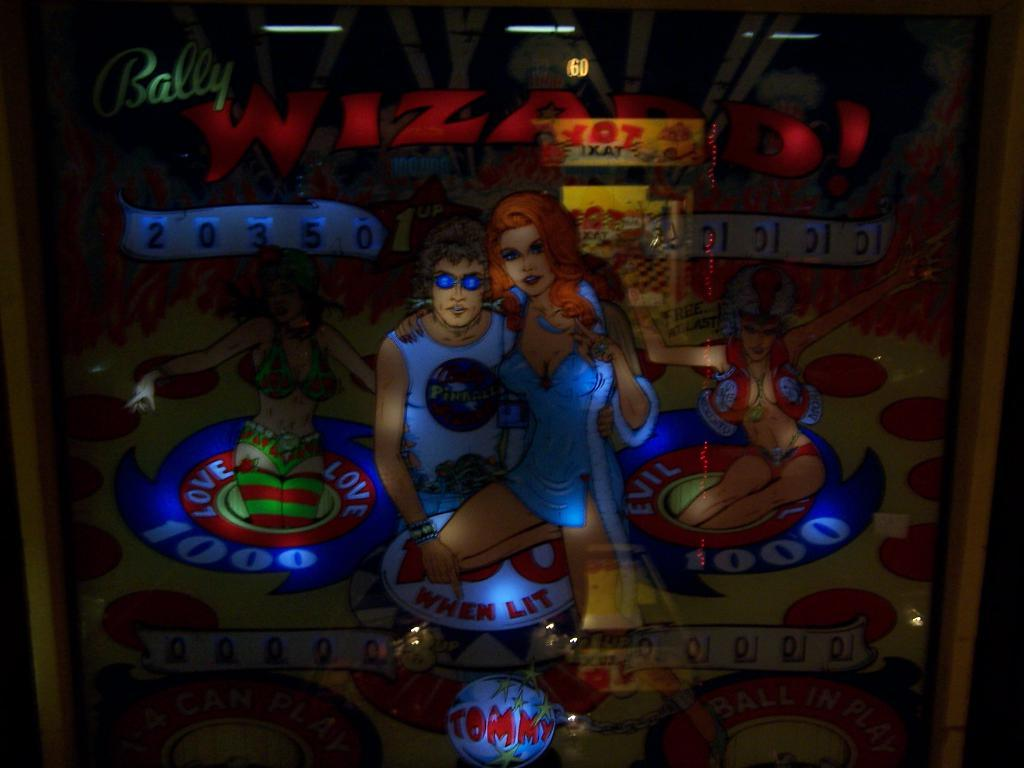<image>
Provide a brief description of the given image. the semi lit back board of a pizza themed pinball machine. 